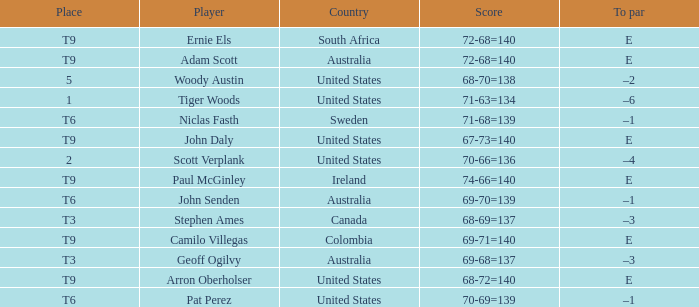Which player is from Sweden? Niclas Fasth. 